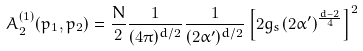Convert formula to latex. <formula><loc_0><loc_0><loc_500><loc_500>A _ { 2 } ^ { ( 1 ) } ( p _ { 1 } , p _ { 2 } ) = \frac { N } { 2 } \frac { 1 } { ( 4 \pi ) ^ { d / 2 } } \frac { 1 } { ( 2 \alpha ^ { \prime } ) ^ { d / 2 } } \left [ 2 g _ { s } ( 2 \alpha ^ { \prime } ) ^ { \frac { d - 2 } { 4 } } \right ] ^ { 2 }</formula> 